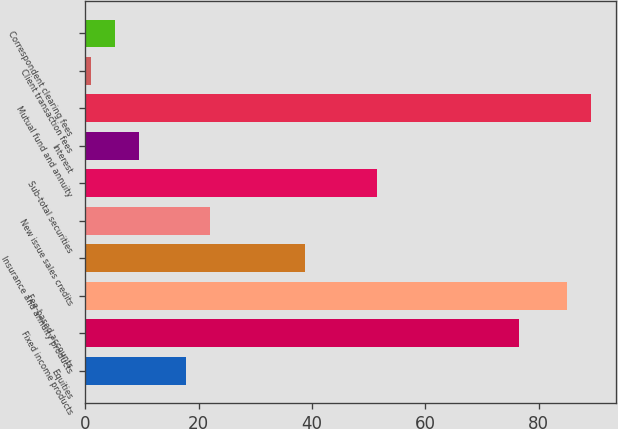Convert chart. <chart><loc_0><loc_0><loc_500><loc_500><bar_chart><fcel>Equities<fcel>Fixed income products<fcel>Fee-based accounts<fcel>Insurance and annuity products<fcel>New issue sales credits<fcel>Sub-total securities<fcel>Interest<fcel>Mutual fund and annuity<fcel>Client transaction fees<fcel>Correspondent clearing fees<nl><fcel>17.8<fcel>76.6<fcel>85<fcel>38.8<fcel>22<fcel>51.4<fcel>9.4<fcel>89.2<fcel>1<fcel>5.2<nl></chart> 